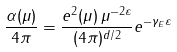Convert formula to latex. <formula><loc_0><loc_0><loc_500><loc_500>\frac { \alpha ( \mu ) } { 4 \pi } = \frac { e ^ { 2 } ( \mu ) \, \mu ^ { - 2 \varepsilon } } { ( 4 \pi ) ^ { d / 2 } } e ^ { - \gamma _ { E } \varepsilon }</formula> 